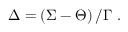<formula> <loc_0><loc_0><loc_500><loc_500>\Delta = \left ( \Sigma - \Theta \right ) / \Gamma \ .</formula> 